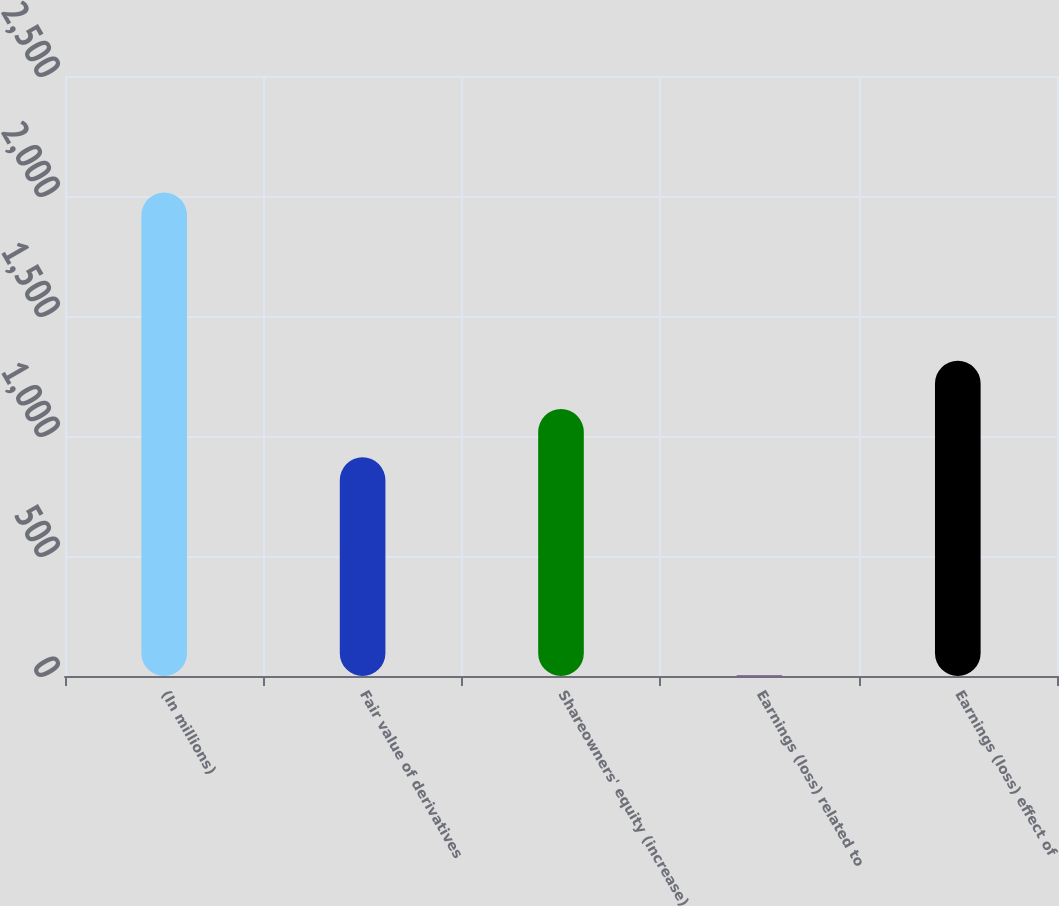Convert chart. <chart><loc_0><loc_0><loc_500><loc_500><bar_chart><fcel>(In millions)<fcel>Fair value of derivatives<fcel>Shareowners' equity (increase)<fcel>Earnings (loss) related to<fcel>Earnings (loss) effect of<nl><fcel>2015<fcel>911<fcel>1112.3<fcel>2<fcel>1313.6<nl></chart> 